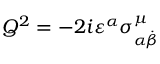Convert formula to latex. <formula><loc_0><loc_0><loc_500><loc_500>Q ^ { 2 } = - 2 i \varepsilon ^ { \alpha } \sigma _ { \alpha \stackrel { . } { \beta } } ^ { \mu } \,</formula> 